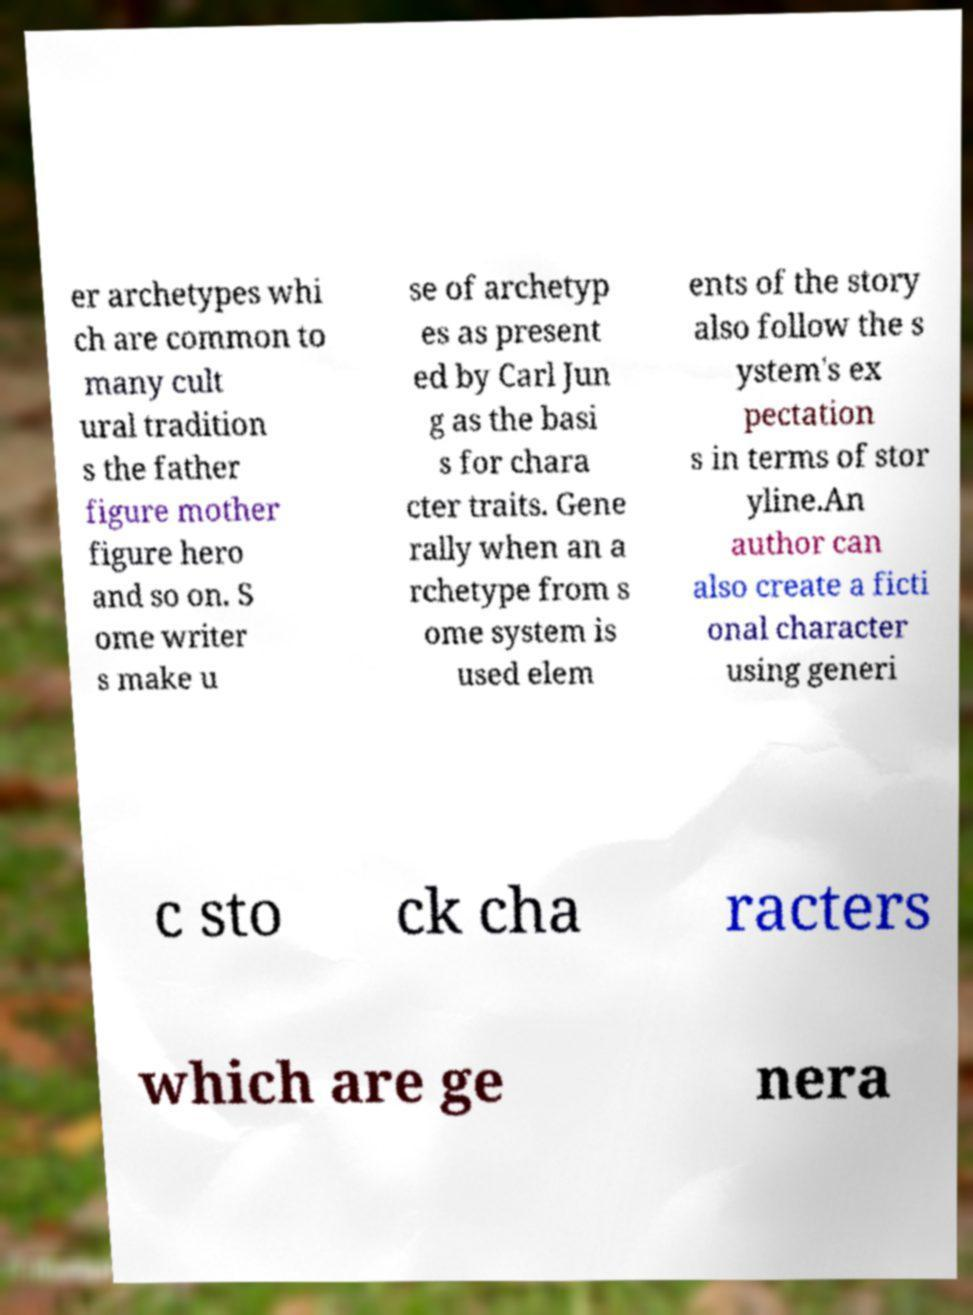Please identify and transcribe the text found in this image. er archetypes whi ch are common to many cult ural tradition s the father figure mother figure hero and so on. S ome writer s make u se of archetyp es as present ed by Carl Jun g as the basi s for chara cter traits. Gene rally when an a rchetype from s ome system is used elem ents of the story also follow the s ystem's ex pectation s in terms of stor yline.An author can also create a ficti onal character using generi c sto ck cha racters which are ge nera 